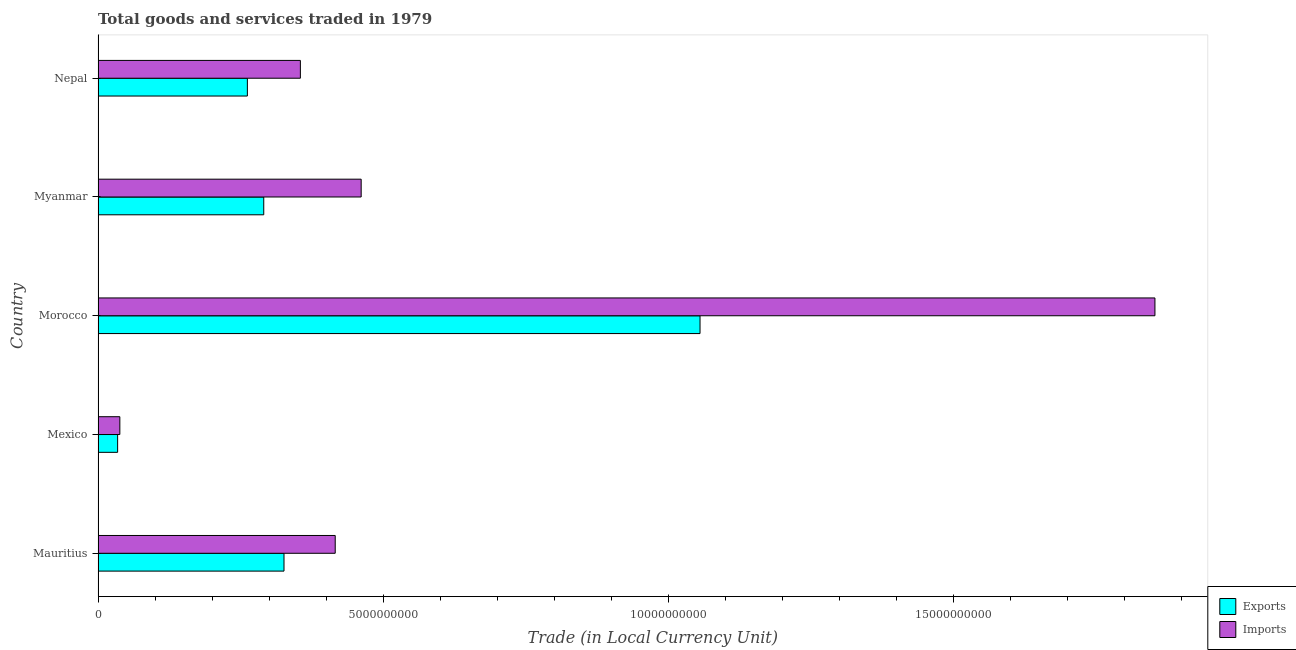How many different coloured bars are there?
Your answer should be very brief. 2. How many groups of bars are there?
Make the answer very short. 5. Are the number of bars per tick equal to the number of legend labels?
Keep it short and to the point. Yes. Are the number of bars on each tick of the Y-axis equal?
Keep it short and to the point. Yes. What is the label of the 1st group of bars from the top?
Your answer should be very brief. Nepal. In how many cases, is the number of bars for a given country not equal to the number of legend labels?
Your answer should be very brief. 0. What is the export of goods and services in Myanmar?
Your answer should be very brief. 2.90e+09. Across all countries, what is the maximum export of goods and services?
Your answer should be compact. 1.06e+1. Across all countries, what is the minimum imports of goods and services?
Provide a succinct answer. 3.82e+08. In which country was the imports of goods and services maximum?
Give a very brief answer. Morocco. In which country was the export of goods and services minimum?
Your answer should be very brief. Mexico. What is the total imports of goods and services in the graph?
Offer a terse response. 3.12e+1. What is the difference between the imports of goods and services in Mexico and that in Nepal?
Your answer should be compact. -3.17e+09. What is the difference between the export of goods and services in Morocco and the imports of goods and services in Mauritius?
Offer a very short reply. 6.40e+09. What is the average export of goods and services per country?
Your answer should be compact. 3.94e+09. What is the difference between the export of goods and services and imports of goods and services in Myanmar?
Provide a short and direct response. -1.71e+09. What is the ratio of the imports of goods and services in Mauritius to that in Myanmar?
Your answer should be very brief. 0.9. Is the difference between the export of goods and services in Morocco and Nepal greater than the difference between the imports of goods and services in Morocco and Nepal?
Your answer should be compact. No. What is the difference between the highest and the second highest export of goods and services?
Provide a succinct answer. 7.29e+09. What is the difference between the highest and the lowest imports of goods and services?
Your answer should be compact. 1.81e+1. Is the sum of the imports of goods and services in Mauritius and Myanmar greater than the maximum export of goods and services across all countries?
Your response must be concise. No. What does the 1st bar from the top in Mauritius represents?
Give a very brief answer. Imports. What does the 2nd bar from the bottom in Nepal represents?
Give a very brief answer. Imports. How many bars are there?
Your answer should be compact. 10. How many countries are there in the graph?
Your answer should be compact. 5. What is the difference between two consecutive major ticks on the X-axis?
Your answer should be compact. 5.00e+09. Does the graph contain any zero values?
Offer a very short reply. No. Where does the legend appear in the graph?
Your answer should be compact. Bottom right. How many legend labels are there?
Keep it short and to the point. 2. What is the title of the graph?
Offer a terse response. Total goods and services traded in 1979. Does "Arms exports" appear as one of the legend labels in the graph?
Make the answer very short. No. What is the label or title of the X-axis?
Your response must be concise. Trade (in Local Currency Unit). What is the label or title of the Y-axis?
Give a very brief answer. Country. What is the Trade (in Local Currency Unit) in Exports in Mauritius?
Ensure brevity in your answer.  3.26e+09. What is the Trade (in Local Currency Unit) in Imports in Mauritius?
Your answer should be very brief. 4.16e+09. What is the Trade (in Local Currency Unit) of Exports in Mexico?
Offer a terse response. 3.43e+08. What is the Trade (in Local Currency Unit) in Imports in Mexico?
Offer a terse response. 3.82e+08. What is the Trade (in Local Currency Unit) of Exports in Morocco?
Your response must be concise. 1.06e+1. What is the Trade (in Local Currency Unit) of Imports in Morocco?
Make the answer very short. 1.85e+1. What is the Trade (in Local Currency Unit) of Exports in Myanmar?
Provide a short and direct response. 2.90e+09. What is the Trade (in Local Currency Unit) of Imports in Myanmar?
Provide a short and direct response. 4.61e+09. What is the Trade (in Local Currency Unit) in Exports in Nepal?
Your answer should be very brief. 2.62e+09. What is the Trade (in Local Currency Unit) in Imports in Nepal?
Give a very brief answer. 3.55e+09. Across all countries, what is the maximum Trade (in Local Currency Unit) of Exports?
Your response must be concise. 1.06e+1. Across all countries, what is the maximum Trade (in Local Currency Unit) in Imports?
Keep it short and to the point. 1.85e+1. Across all countries, what is the minimum Trade (in Local Currency Unit) of Exports?
Your response must be concise. 3.43e+08. Across all countries, what is the minimum Trade (in Local Currency Unit) of Imports?
Your answer should be very brief. 3.82e+08. What is the total Trade (in Local Currency Unit) in Exports in the graph?
Keep it short and to the point. 1.97e+1. What is the total Trade (in Local Currency Unit) of Imports in the graph?
Provide a succinct answer. 3.12e+1. What is the difference between the Trade (in Local Currency Unit) in Exports in Mauritius and that in Mexico?
Give a very brief answer. 2.92e+09. What is the difference between the Trade (in Local Currency Unit) of Imports in Mauritius and that in Mexico?
Offer a very short reply. 3.78e+09. What is the difference between the Trade (in Local Currency Unit) of Exports in Mauritius and that in Morocco?
Your answer should be compact. -7.29e+09. What is the difference between the Trade (in Local Currency Unit) in Imports in Mauritius and that in Morocco?
Offer a terse response. -1.44e+1. What is the difference between the Trade (in Local Currency Unit) of Exports in Mauritius and that in Myanmar?
Your response must be concise. 3.55e+08. What is the difference between the Trade (in Local Currency Unit) in Imports in Mauritius and that in Myanmar?
Give a very brief answer. -4.55e+08. What is the difference between the Trade (in Local Currency Unit) of Exports in Mauritius and that in Nepal?
Give a very brief answer. 6.42e+08. What is the difference between the Trade (in Local Currency Unit) of Imports in Mauritius and that in Nepal?
Offer a very short reply. 6.11e+08. What is the difference between the Trade (in Local Currency Unit) in Exports in Mexico and that in Morocco?
Your answer should be compact. -1.02e+1. What is the difference between the Trade (in Local Currency Unit) of Imports in Mexico and that in Morocco?
Your answer should be compact. -1.81e+1. What is the difference between the Trade (in Local Currency Unit) of Exports in Mexico and that in Myanmar?
Give a very brief answer. -2.56e+09. What is the difference between the Trade (in Local Currency Unit) in Imports in Mexico and that in Myanmar?
Provide a short and direct response. -4.23e+09. What is the difference between the Trade (in Local Currency Unit) in Exports in Mexico and that in Nepal?
Give a very brief answer. -2.27e+09. What is the difference between the Trade (in Local Currency Unit) in Imports in Mexico and that in Nepal?
Provide a short and direct response. -3.17e+09. What is the difference between the Trade (in Local Currency Unit) of Exports in Morocco and that in Myanmar?
Your answer should be compact. 7.65e+09. What is the difference between the Trade (in Local Currency Unit) in Imports in Morocco and that in Myanmar?
Ensure brevity in your answer.  1.39e+1. What is the difference between the Trade (in Local Currency Unit) in Exports in Morocco and that in Nepal?
Your response must be concise. 7.94e+09. What is the difference between the Trade (in Local Currency Unit) of Imports in Morocco and that in Nepal?
Give a very brief answer. 1.50e+1. What is the difference between the Trade (in Local Currency Unit) of Exports in Myanmar and that in Nepal?
Give a very brief answer. 2.87e+08. What is the difference between the Trade (in Local Currency Unit) in Imports in Myanmar and that in Nepal?
Provide a short and direct response. 1.07e+09. What is the difference between the Trade (in Local Currency Unit) in Exports in Mauritius and the Trade (in Local Currency Unit) in Imports in Mexico?
Your answer should be compact. 2.88e+09. What is the difference between the Trade (in Local Currency Unit) in Exports in Mauritius and the Trade (in Local Currency Unit) in Imports in Morocco?
Provide a succinct answer. -1.53e+1. What is the difference between the Trade (in Local Currency Unit) in Exports in Mauritius and the Trade (in Local Currency Unit) in Imports in Myanmar?
Your answer should be compact. -1.35e+09. What is the difference between the Trade (in Local Currency Unit) in Exports in Mauritius and the Trade (in Local Currency Unit) in Imports in Nepal?
Give a very brief answer. -2.87e+08. What is the difference between the Trade (in Local Currency Unit) of Exports in Mexico and the Trade (in Local Currency Unit) of Imports in Morocco?
Offer a very short reply. -1.82e+1. What is the difference between the Trade (in Local Currency Unit) in Exports in Mexico and the Trade (in Local Currency Unit) in Imports in Myanmar?
Ensure brevity in your answer.  -4.27e+09. What is the difference between the Trade (in Local Currency Unit) of Exports in Mexico and the Trade (in Local Currency Unit) of Imports in Nepal?
Provide a succinct answer. -3.20e+09. What is the difference between the Trade (in Local Currency Unit) of Exports in Morocco and the Trade (in Local Currency Unit) of Imports in Myanmar?
Your response must be concise. 5.94e+09. What is the difference between the Trade (in Local Currency Unit) in Exports in Morocco and the Trade (in Local Currency Unit) in Imports in Nepal?
Offer a very short reply. 7.01e+09. What is the difference between the Trade (in Local Currency Unit) in Exports in Myanmar and the Trade (in Local Currency Unit) in Imports in Nepal?
Provide a short and direct response. -6.42e+08. What is the average Trade (in Local Currency Unit) of Exports per country?
Give a very brief answer. 3.94e+09. What is the average Trade (in Local Currency Unit) of Imports per country?
Provide a short and direct response. 6.25e+09. What is the difference between the Trade (in Local Currency Unit) in Exports and Trade (in Local Currency Unit) in Imports in Mauritius?
Give a very brief answer. -8.98e+08. What is the difference between the Trade (in Local Currency Unit) of Exports and Trade (in Local Currency Unit) of Imports in Mexico?
Provide a short and direct response. -3.87e+07. What is the difference between the Trade (in Local Currency Unit) in Exports and Trade (in Local Currency Unit) in Imports in Morocco?
Your response must be concise. -7.98e+09. What is the difference between the Trade (in Local Currency Unit) in Exports and Trade (in Local Currency Unit) in Imports in Myanmar?
Provide a short and direct response. -1.71e+09. What is the difference between the Trade (in Local Currency Unit) of Exports and Trade (in Local Currency Unit) of Imports in Nepal?
Keep it short and to the point. -9.29e+08. What is the ratio of the Trade (in Local Currency Unit) in Exports in Mauritius to that in Mexico?
Provide a short and direct response. 9.5. What is the ratio of the Trade (in Local Currency Unit) of Imports in Mauritius to that in Mexico?
Offer a very short reply. 10.88. What is the ratio of the Trade (in Local Currency Unit) in Exports in Mauritius to that in Morocco?
Give a very brief answer. 0.31. What is the ratio of the Trade (in Local Currency Unit) of Imports in Mauritius to that in Morocco?
Keep it short and to the point. 0.22. What is the ratio of the Trade (in Local Currency Unit) in Exports in Mauritius to that in Myanmar?
Provide a succinct answer. 1.12. What is the ratio of the Trade (in Local Currency Unit) of Imports in Mauritius to that in Myanmar?
Ensure brevity in your answer.  0.9. What is the ratio of the Trade (in Local Currency Unit) of Exports in Mauritius to that in Nepal?
Keep it short and to the point. 1.25. What is the ratio of the Trade (in Local Currency Unit) of Imports in Mauritius to that in Nepal?
Your answer should be very brief. 1.17. What is the ratio of the Trade (in Local Currency Unit) in Exports in Mexico to that in Morocco?
Give a very brief answer. 0.03. What is the ratio of the Trade (in Local Currency Unit) of Imports in Mexico to that in Morocco?
Offer a terse response. 0.02. What is the ratio of the Trade (in Local Currency Unit) in Exports in Mexico to that in Myanmar?
Ensure brevity in your answer.  0.12. What is the ratio of the Trade (in Local Currency Unit) of Imports in Mexico to that in Myanmar?
Your answer should be very brief. 0.08. What is the ratio of the Trade (in Local Currency Unit) in Exports in Mexico to that in Nepal?
Your response must be concise. 0.13. What is the ratio of the Trade (in Local Currency Unit) of Imports in Mexico to that in Nepal?
Your answer should be compact. 0.11. What is the ratio of the Trade (in Local Currency Unit) in Exports in Morocco to that in Myanmar?
Provide a short and direct response. 3.63. What is the ratio of the Trade (in Local Currency Unit) of Imports in Morocco to that in Myanmar?
Provide a short and direct response. 4.02. What is the ratio of the Trade (in Local Currency Unit) in Exports in Morocco to that in Nepal?
Ensure brevity in your answer.  4.03. What is the ratio of the Trade (in Local Currency Unit) in Imports in Morocco to that in Nepal?
Offer a very short reply. 5.22. What is the ratio of the Trade (in Local Currency Unit) in Exports in Myanmar to that in Nepal?
Your answer should be very brief. 1.11. What is the ratio of the Trade (in Local Currency Unit) of Imports in Myanmar to that in Nepal?
Provide a short and direct response. 1.3. What is the difference between the highest and the second highest Trade (in Local Currency Unit) in Exports?
Your answer should be very brief. 7.29e+09. What is the difference between the highest and the second highest Trade (in Local Currency Unit) of Imports?
Ensure brevity in your answer.  1.39e+1. What is the difference between the highest and the lowest Trade (in Local Currency Unit) in Exports?
Make the answer very short. 1.02e+1. What is the difference between the highest and the lowest Trade (in Local Currency Unit) of Imports?
Give a very brief answer. 1.81e+1. 